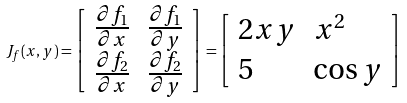<formula> <loc_0><loc_0><loc_500><loc_500>J _ { f } ( x , y ) = { \left [ \begin{array} { l l } { { \frac { \partial f _ { 1 } } { \partial x } } } & { { \frac { \partial f _ { 1 } } { \partial y } } } \\ { { \frac { \partial f _ { 2 } } { \partial x } } } & { { \frac { \partial f _ { 2 } } { \partial y } } } \end{array} \right ] } = { \left [ \begin{array} { l l } { 2 x y } & { x ^ { 2 } } \\ { 5 } & { \cos y } \end{array} \right ] }</formula> 